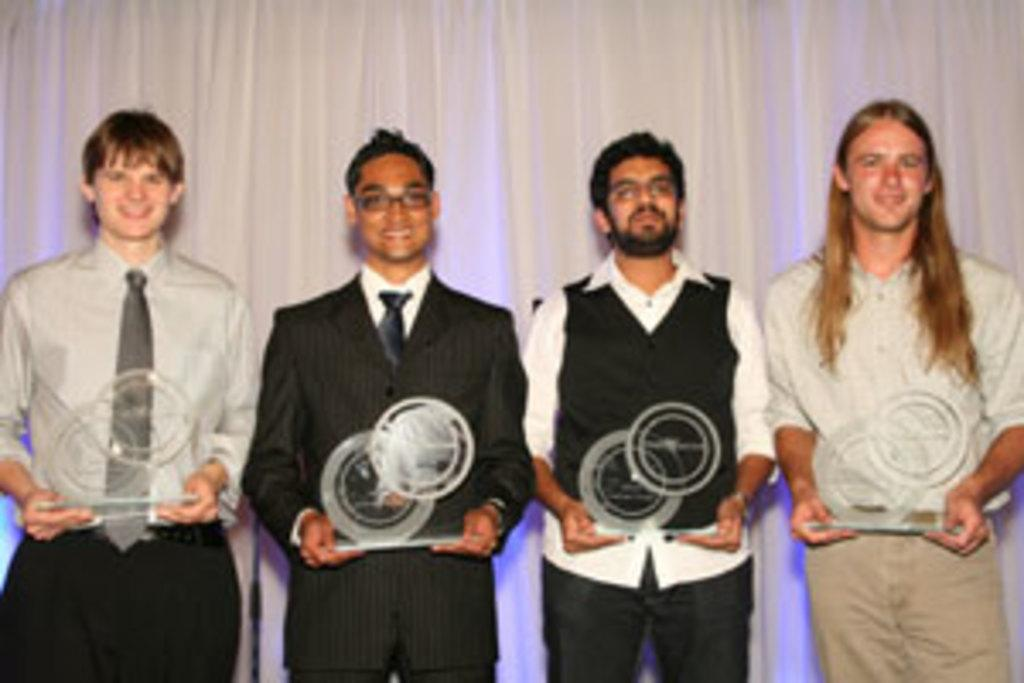How many people are in the image? There are four people in the image. What are the people doing in the image? The people are smiling and holding trophies. What can be seen in the background of the image? There is a curtain visible in the background of the image. How many servants are present in the image? There is no mention of servants in the image; it only features four people holding trophies. What type of glass is being used by the women in the image? There is no mention of women or glass in the image; it only features four people holding trophies. 